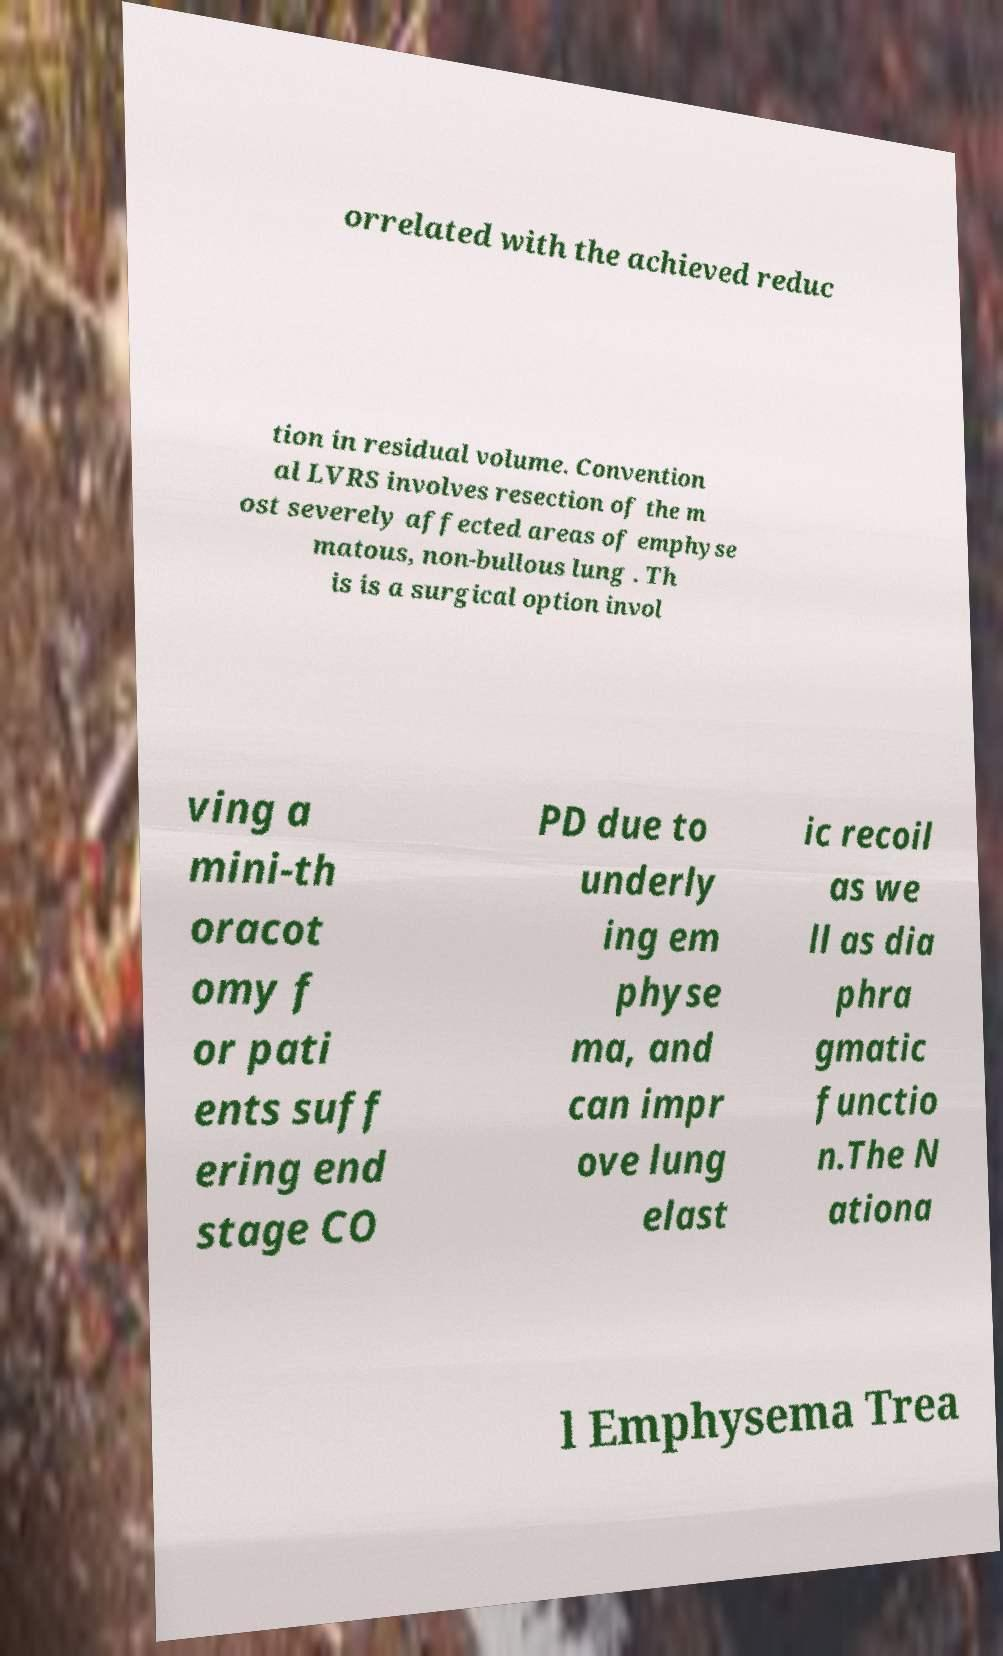Can you read and provide the text displayed in the image?This photo seems to have some interesting text. Can you extract and type it out for me? orrelated with the achieved reduc tion in residual volume. Convention al LVRS involves resection of the m ost severely affected areas of emphyse matous, non-bullous lung . Th is is a surgical option invol ving a mini-th oracot omy f or pati ents suff ering end stage CO PD due to underly ing em physe ma, and can impr ove lung elast ic recoil as we ll as dia phra gmatic functio n.The N ationa l Emphysema Trea 